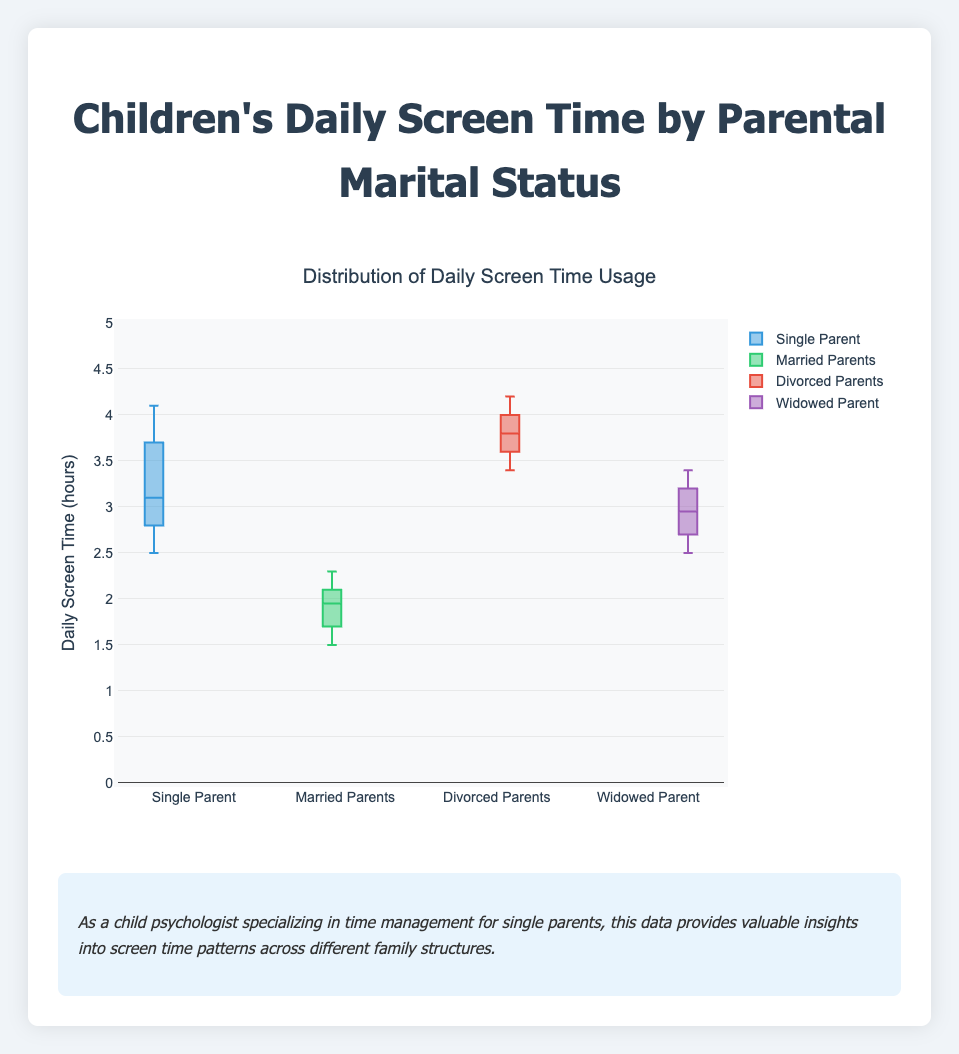What's the title of the figure? The title is usually displayed prominently at the top of the figure. In this case, the title is "Distribution of Daily Screen Time Usage".
Answer: Distribution of Daily Screen Time Usage Which group has the highest median daily screen time? The median is typically represented by a line inside the box of a box plot. In this figure, the box for "Divorced Parents" has the highest median line at around 3.8 hours.
Answer: Divorced Parents What is the y-axis measuring? The y-axis usually displays the variable being measured. Here, it measures "Daily Screen Time (hours)".
Answer: Daily Screen Time (hours) Which group has the smallest range of daily screen time? The range is the difference between the maximum and minimum values. The boxplot for "Married Parents" is the shortest, indicating it has the smallest range.
Answer: Married Parents Compare the quartiles of "Single Parent" and "Widowed Parent". Which has a larger interquartile range (IQR)? The interquartile range (IQR) is the height of the box itself. The "Single Parent" box is taller than the "Widowed Parent" box, indicating a larger IQR.
Answer: Single Parent Which group shows the greatest variability in daily screen time? Variability can be inferred from the spread of the data. The "Divorced Parents" group has the widest box and whiskers, indicating the greatest variability.
Answer: Divorced Parents What is the upper quartile (Q3) value for "Married Parents"? In a box plot, the upper edge of the box is the third quartile. For "Married Parents", Q3 is at 2.2 hours.
Answer: 2.2 hours Which group has the most outliers? In a box plot, outliers are shown as individual points outside the whiskers. None of the groups show outliers in this figure.
Answer: No group has outliers What is the median screen time for children with widowed parents? The median is the line in the center of the box. For "Widowed Parent", the median is around 2.9 hours.
Answer: 2.9 hours How does the screen time of children with single parents compare to those with divorced parents? Comparing the number of data points and quartiles, both groups have higher screen times, but "Divorced Parents" has a higher median and wider range.
Answer: Divorced Parents have higher screen time 